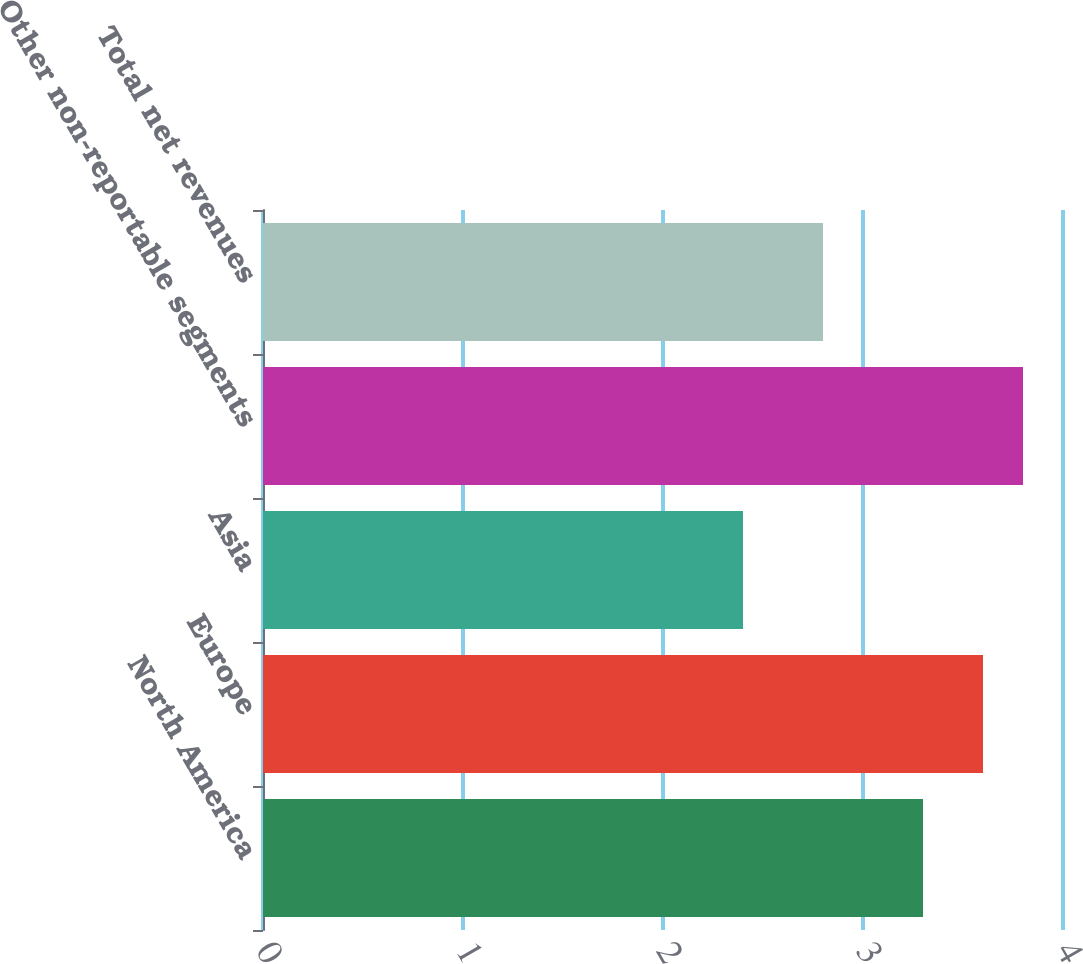Convert chart. <chart><loc_0><loc_0><loc_500><loc_500><bar_chart><fcel>North America<fcel>Europe<fcel>Asia<fcel>Other non-reportable segments<fcel>Total net revenues<nl><fcel>3.3<fcel>3.6<fcel>2.4<fcel>3.8<fcel>2.8<nl></chart> 